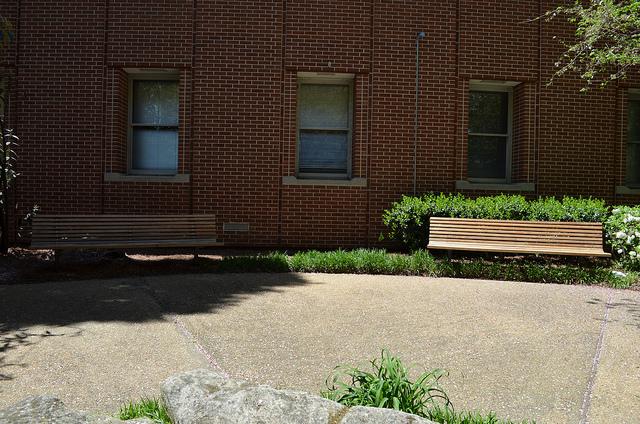Are the benches made of stone?
Give a very brief answer. No. What's the building made of?
Short answer required. Brick. Are there benches in front of the building?
Quick response, please. Yes. What is the building made of?
Keep it brief. Brick. Is there a park nearby?
Be succinct. Yes. What style of trim does the building have?
Short answer required. Brick. What are the walls made out of?
Give a very brief answer. Brick. Is this somebody's backyard?
Write a very short answer. No. 